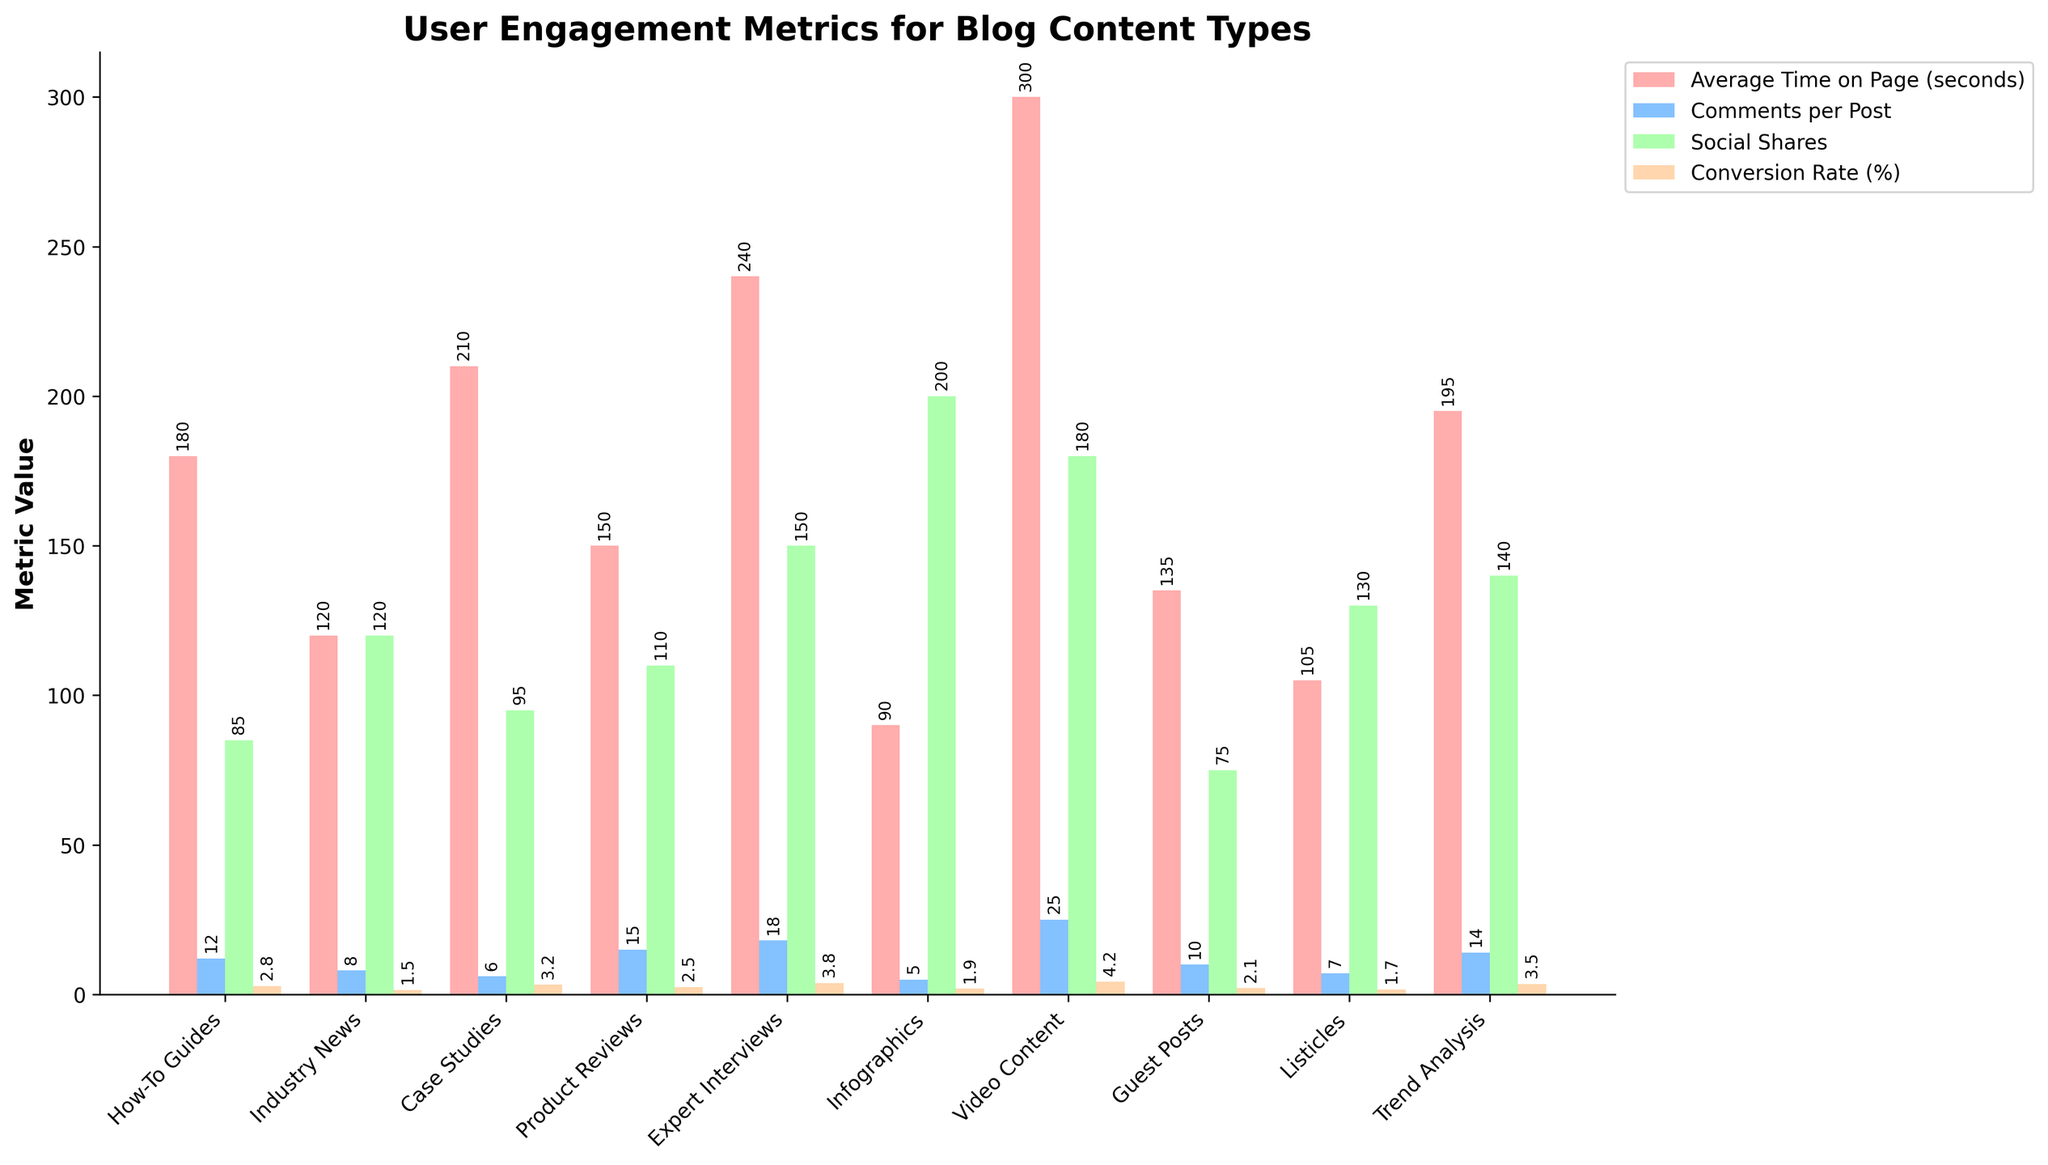Which content type has the highest average time on the page? The bar for "Video Content" is the tallest in the "Average Time on Page (seconds)" category, indicating it has the highest value compared to other content types.
Answer: Video Content Which content type has the lowest conversion rate? The bar for "Industry News" is the shortest in the "Conversion Rate (%)" category, indicating it has the lowest value compared to other content types.
Answer: Industry News By how many seconds is the average time on the page for "Case Studies" greater than "Listicles"? The average time on the page for "Case Studies" is 210 seconds, and for "Listicles" it is 105 seconds. Subtracting the two values gives 210 - 105 = 105 seconds.
Answer: 105 seconds Which content type has the highest number of comments per post and how many are there? The bar for "Video Content" is the tallest in the "Comments per Post" category, indicating it has the highest number of comments per post, which is 25.
Answer: Video Content, 25 How many more social shares do "Infographics" have compared to "Guest Posts"? The bar for "Infographics" in the "Social Shares" category is at 200, and "Guest Posts" is at 75. Subtracting the two values gives 200 - 75 = 125 more social shares.
Answer: 125 Which two content types have the closest conversion rates and what are their values? The bars for "Product Reviews" and "Guest Posts" in the "Conversion Rate (%)" category are closest to each other. "Product Reviews" has a conversion rate of 2.5%, and "Guest Posts" has a conversion rate of 2.1%.
Answer: Product Reviews, 2.5% and Guest Posts, 2.1% What is the combined total of social shares for "How-To Guides" and "Expert Interviews"? The "Social Shares" values for "How-To Guides" and "Expert Interviews" are 85 and 150, respectively. Adding these values gives 85 + 150 = 235.
Answer: 235 Considering "Average Time on Page," "Comments per Post," and "Social Shares," which content type scores highest in all three metrics? The bar for "Video Content" is the tallest in "Average Time on Page (seconds)," "Comments per Post," and "Social Shares," indicating it leads in all three metrics.
Answer: Video Content On average, which content type performed better in "Social Shares": "Trend Analysis" or "Listicles"? The bar for "Trend Analysis" in the "Social Shares" category is at 140, while the bar for "Listicles" is at 130. Since 140 is greater than 130, "Trend Analysis" performed better.
Answer: Trend Analysis How much higher is the conversion rate for "Expert Interviews" compared to "Industry News"? The "Conversion Rate (%)" for "Expert Interviews" is 3.8%, and for "Industry News" it is 1.5%. Subtracting these values gives 3.8% - 1.5% = 2.3%.
Answer: 2.3% 